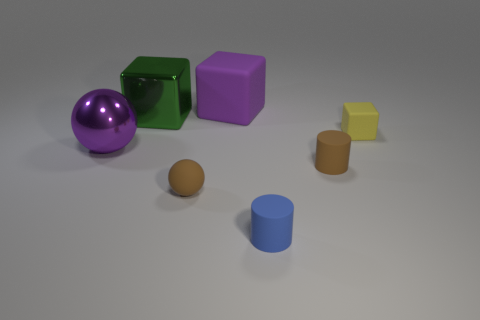Is the number of metallic balls greater than the number of blocks?
Your answer should be compact. No. Do the green thing and the purple shiny ball have the same size?
Give a very brief answer. Yes. How many objects are either big metal blocks or yellow rubber things?
Provide a short and direct response. 2. There is a small brown matte object right of the rubber block that is behind the block right of the small blue thing; what is its shape?
Your response must be concise. Cylinder. Is the material of the big cube that is in front of the large matte thing the same as the block on the right side of the brown cylinder?
Give a very brief answer. No. There is a purple thing that is the same shape as the small yellow rubber thing; what is its material?
Offer a terse response. Rubber. Is there any other thing that is the same size as the green object?
Make the answer very short. Yes. Do the tiny rubber thing in front of the tiny brown ball and the tiny brown object right of the blue cylinder have the same shape?
Make the answer very short. Yes. Is the number of things behind the blue object less than the number of large green blocks to the right of the brown sphere?
Keep it short and to the point. No. How many other objects are the same shape as the large green shiny thing?
Keep it short and to the point. 2. 